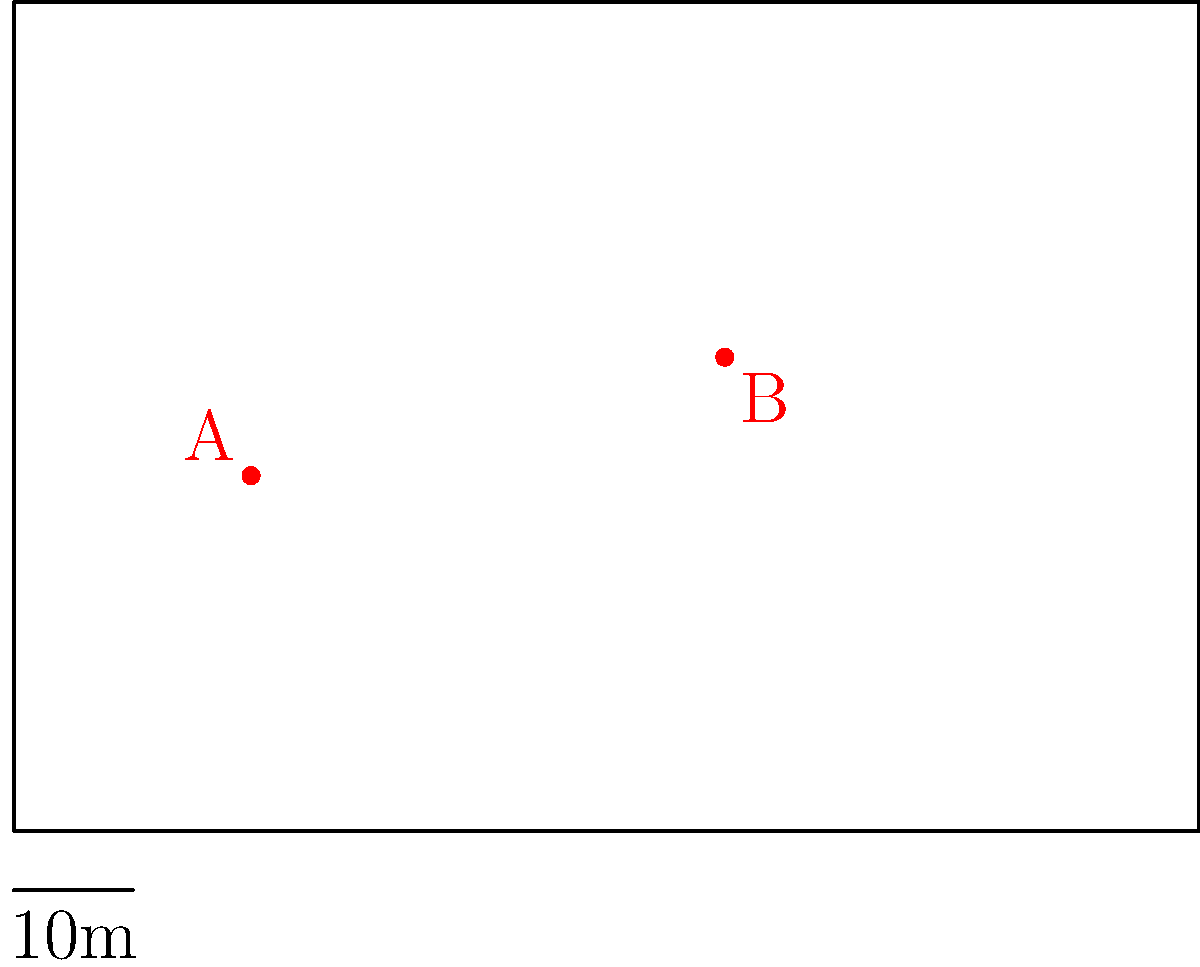Using drone footage, you've captured two frames of a player's movement on the soccer field. In the first frame, the player is at point A, and in the second frame, taken 3 seconds later, the player is at point B. Given that each small square on the grid represents 10m x 10m, calculate the player's average speed between these two points in km/h. To solve this problem, we'll follow these steps:

1. Calculate the distance between points A and B:
   - A is at approximately (20, 30) and B is at (60, 40)
   - Using the Pythagorean theorem: 
     $$d = \sqrt{(x_2-x_1)^2 + (y_2-y_1)^2}$$
     $$d = \sqrt{(60-20)^2 + (40-30)^2}$$
     $$d = \sqrt{40^2 + 10^2} = \sqrt{1600 + 100} = \sqrt{1700}$$
   - Each unit is 10m, so the distance is:
     $$d = 10 \cdot \sqrt{1700} \approx 41.23 \text{ meters}$$

2. Calculate the speed:
   - Time taken = 3 seconds
   - Speed = Distance / Time
   $$v = \frac{41.23 \text{ m}}{3 \text{ s}} \approx 13.74 \text{ m/s}$$

3. Convert m/s to km/h:
   $$13.74 \text{ m/s} \cdot \frac{3600 \text{ s}}{1 \text{ h}} \cdot \frac{1 \text{ km}}{1000 \text{ m}} \approx 49.46 \text{ km/h}$$

Therefore, the player's average speed is approximately 49.46 km/h.
Answer: 49.46 km/h 